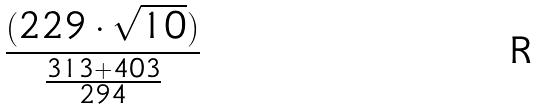Convert formula to latex. <formula><loc_0><loc_0><loc_500><loc_500>\frac { ( 2 2 9 \cdot \sqrt { 1 0 } ) } { \frac { 3 1 3 + 4 0 3 } { 2 9 4 } }</formula> 